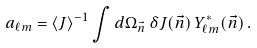<formula> <loc_0><loc_0><loc_500><loc_500>a _ { \ell m } = \langle J \rangle ^ { - 1 } \int d \Omega _ { \vec { n } } \, \delta J ( \vec { n } ) \, Y _ { \ell m } ^ { \ast } ( \vec { n } ) \, .</formula> 